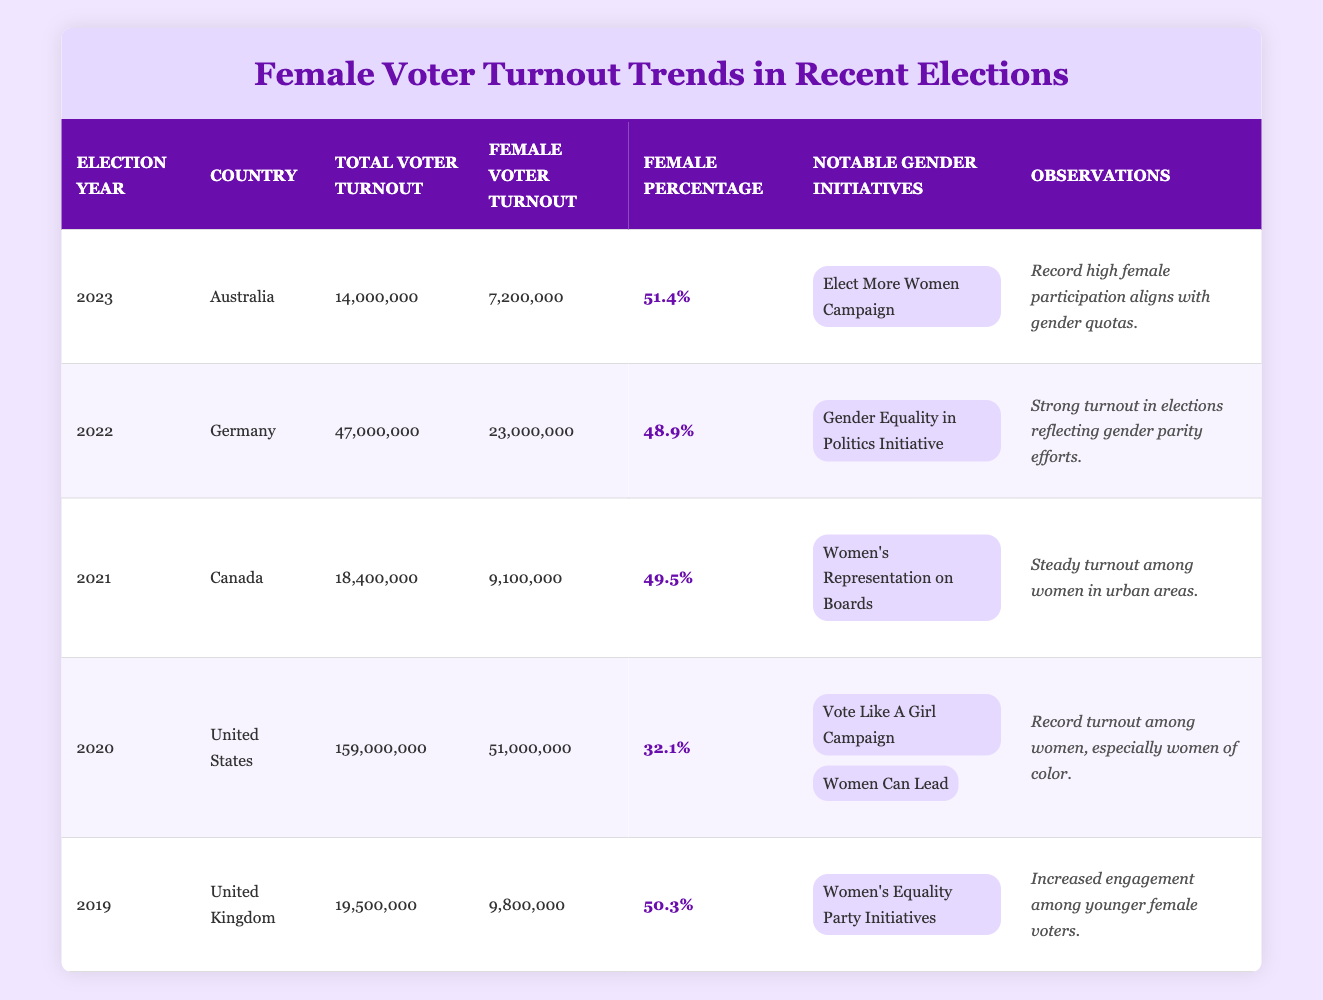What was the total voter turnout in the 2020 United States election? The table indicates that the total voter turnout in the 2020 United States election was 159,000,000, as listed in the "Total Voter Turnout" column for that election year.
Answer: 159,000,000 Which country had the highest percentage of female voter turnout in 2023? Based on the table, Australia had the highest percentage of female voter turnout in 2023, which is 51.4%, referenced in the "Female Percentage" column for that year.
Answer: 51.4% What is the average percentage of female voter turnout across all elections listed in the table? To calculate the average percentage of female voter turnout, add the percentages (32.1 + 50.3 + 49.5 + 48.9 + 51.4) = 232.2. There are 5 elections, so the average is 232.2 / 5 = 46.44.
Answer: 46.44 Did the female voter turnout exceed 50% in any country during the elections listed? By reviewing the "Female Percentage" column in the table, we see that Australia (51.4%) and the United Kingdom (50.3%) both surpassed 50%. Therefore, the answer is yes.
Answer: Yes How many female voters participated in the 2022 Germany elections compared to the 2021 Canada elections? From the table, the number of female voters in Germany in 2022 was 23,000,000, while in Canada in 2021 it was 9,100,000. The difference between these figures is 23,000,000 - 9,100,000 = 13,900,000, indicating that Germany had significantly more female voters.
Answer: Germany had 13,900,000 more female voters What trends can be observed regarding female voter turnout in the last five elections? Observing the table, there is a noticeable trend: the percentage of female voter turnout in 2023 (51.4%) was the highest, followed closely by the UK in 2019 (50.3%). Germany in 2022 (48.9%) and Canada in 2021 (49.5%) showed steady turnout, while the US in 2020 had a notable turnout of 32.1%, suggesting increasing engagement of female voters in recent elections compared to earlier years.
Answer: Increasing engagement Which gender initiative was noted in the table for the United States during the 2020 elections? The table lists two notable gender initiatives for the United States in the 2020 elections, which are the "Vote Like A Girl Campaign" and "Women Can Lead." Therefore, the initiatives show a focus on encouraging female participation in the electoral process.
Answer: Vote Like A Girl Campaign, Women Can Lead In which country did women's voter turnout significantly increase in 2019, and what might have contributed to this? The United Kingdom experienced a significant increase in female voter turnout in 2019, with a female percentage of 50.3%. This increase could be attributed to the "Women's Equality Party Initiatives," which likely fostered greater engagement among female voters, especially the younger demographic.
Answer: United Kingdom; Women's Equality Party Initiatives 